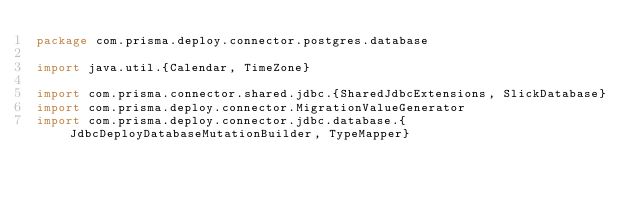<code> <loc_0><loc_0><loc_500><loc_500><_Scala_>package com.prisma.deploy.connector.postgres.database

import java.util.{Calendar, TimeZone}

import com.prisma.connector.shared.jdbc.{SharedJdbcExtensions, SlickDatabase}
import com.prisma.deploy.connector.MigrationValueGenerator
import com.prisma.deploy.connector.jdbc.database.{JdbcDeployDatabaseMutationBuilder, TypeMapper}</code> 